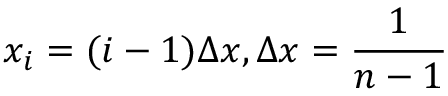<formula> <loc_0><loc_0><loc_500><loc_500>x _ { i } = ( i - 1 ) \Delta x , \Delta x = \frac { 1 } { n - 1 }</formula> 